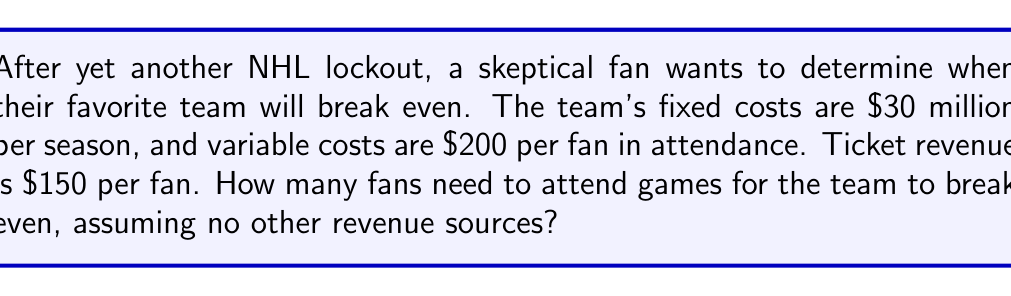Solve this math problem. Let's approach this step-by-step:

1) Define variables:
   Let $x$ = number of fans attending games in a season

2) Set up the revenue equation:
   Revenue = $150 per fan * $x$ fans
   $R = 150x$

3) Set up the cost equation:
   Costs = Fixed costs + Variable costs
   $C = 30,000,000 + 200x$

4) At the break-even point, revenue equals costs:
   $R = C$
   $150x = 30,000,000 + 200x$

5) Solve the equation:
   $150x - 200x = 30,000,000$
   $-50x = 30,000,000$
   $x = -30,000,000 / (-50)$
   $x = 600,000$

Therefore, 600,000 fans need to attend games for the team to break even.

To verify:
Revenue: $150 * 600,000 = $90,000,000
Costs: $30,000,000 + ($200 * 600,000) = $90,000,000

Indeed, revenue equals costs at this point.
Answer: 600,000 fans 